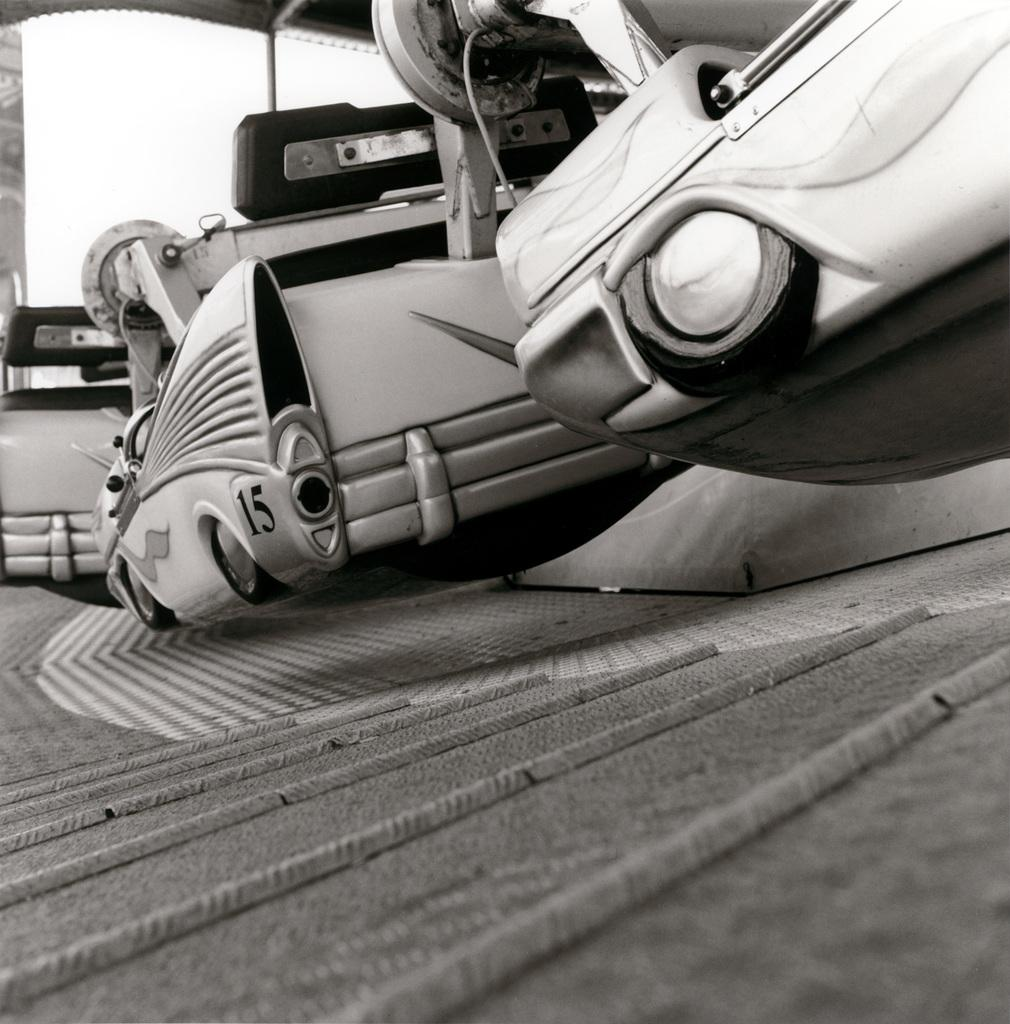What is the color scheme of the image? The image is black and white. What can be seen in the center of the image? There is an object with the number fifteen in the center of the image. What type of writer is depicted in the image? There is no writer depicted in the image; it only features an object with the number fifteen. Can you tell me how many pickles are visible in the image? There are no pickles present in the image. 